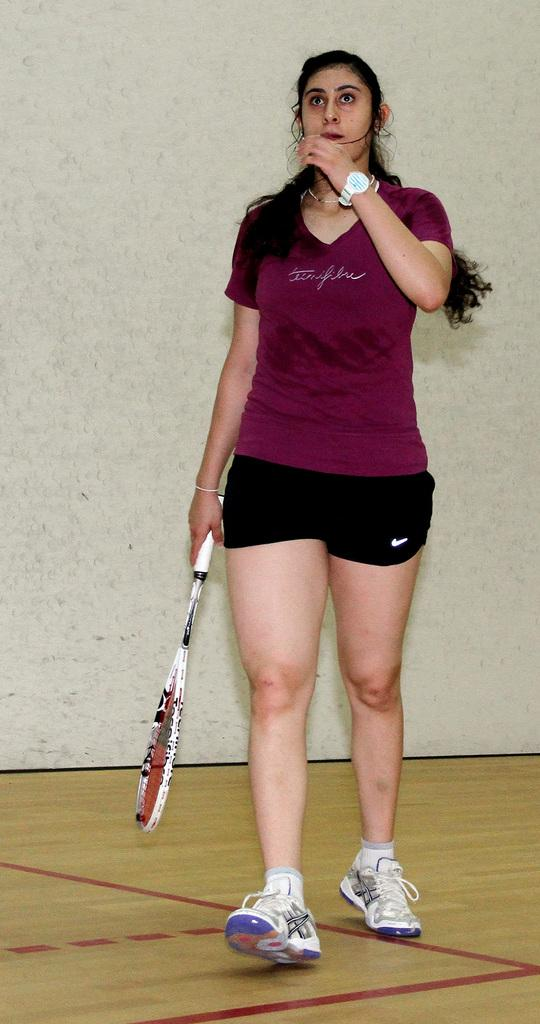Who is present in the image? There is a woman in the image. What is the woman doing in the image? The woman is standing in the image. What accessory is the woman wearing on her wrist? The woman is wearing a watch in the image. What object is the woman holding in her hand? The woman is holding a bat in her hand in the image. What can be seen in the background of the image? There is a wall in the background of the image. What type of footwear is the woman wearing? The woman is wearing shoes in the image. Where is the honey stored in the image? There is no honey present in the image. How many chickens can be seen in the image? There are no chickens present in the image. 